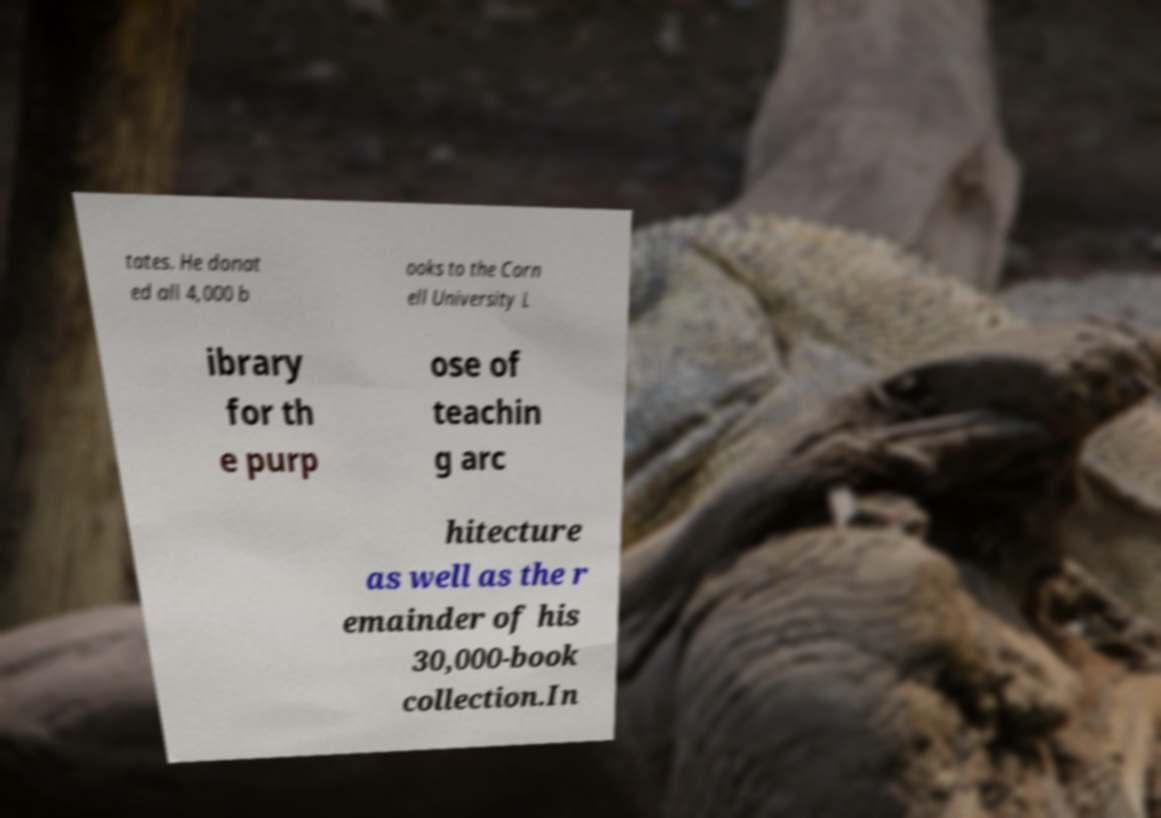Can you accurately transcribe the text from the provided image for me? tates. He donat ed all 4,000 b ooks to the Corn ell University L ibrary for th e purp ose of teachin g arc hitecture as well as the r emainder of his 30,000-book collection.In 